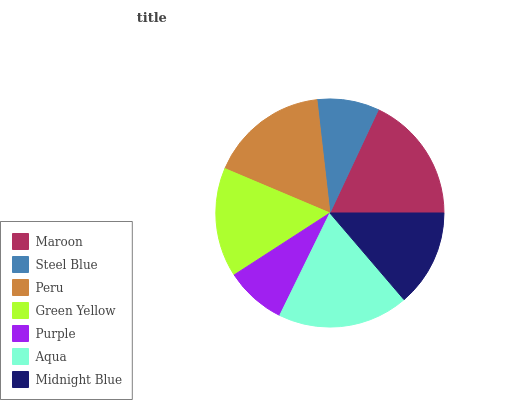Is Purple the minimum?
Answer yes or no. Yes. Is Aqua the maximum?
Answer yes or no. Yes. Is Steel Blue the minimum?
Answer yes or no. No. Is Steel Blue the maximum?
Answer yes or no. No. Is Maroon greater than Steel Blue?
Answer yes or no. Yes. Is Steel Blue less than Maroon?
Answer yes or no. Yes. Is Steel Blue greater than Maroon?
Answer yes or no. No. Is Maroon less than Steel Blue?
Answer yes or no. No. Is Green Yellow the high median?
Answer yes or no. Yes. Is Green Yellow the low median?
Answer yes or no. Yes. Is Aqua the high median?
Answer yes or no. No. Is Aqua the low median?
Answer yes or no. No. 